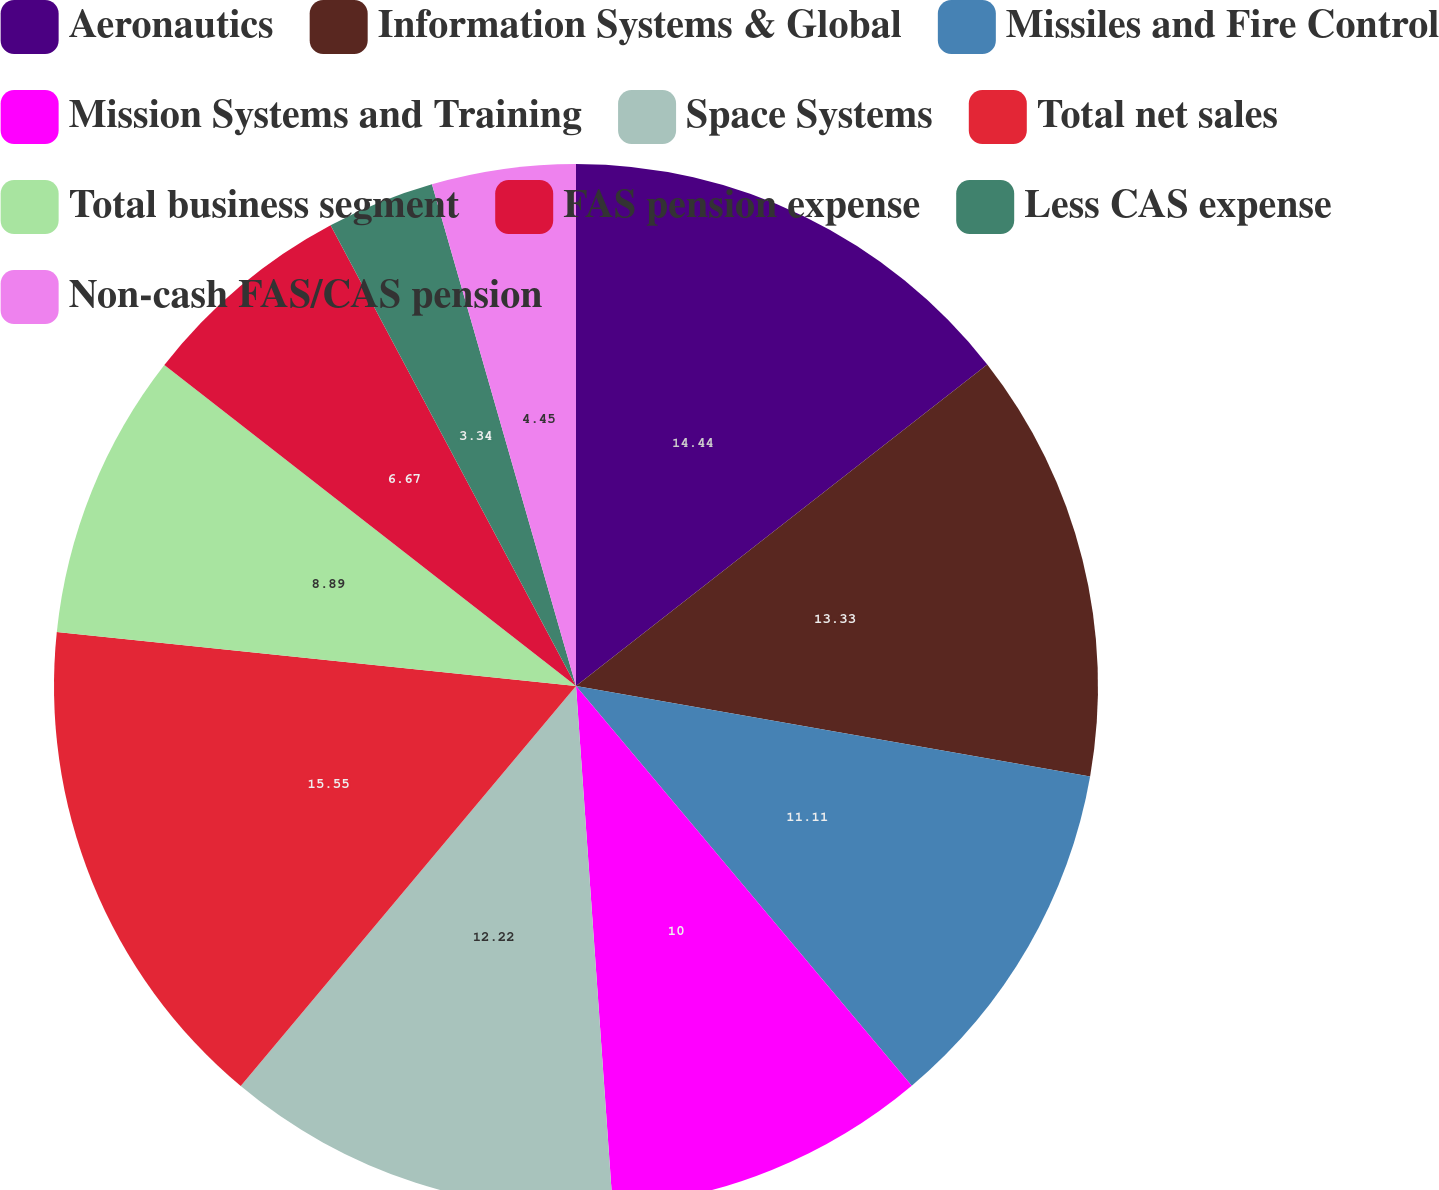<chart> <loc_0><loc_0><loc_500><loc_500><pie_chart><fcel>Aeronautics<fcel>Information Systems & Global<fcel>Missiles and Fire Control<fcel>Mission Systems and Training<fcel>Space Systems<fcel>Total net sales<fcel>Total business segment<fcel>FAS pension expense<fcel>Less CAS expense<fcel>Non-cash FAS/CAS pension<nl><fcel>14.44%<fcel>13.33%<fcel>11.11%<fcel>10.0%<fcel>12.22%<fcel>15.55%<fcel>8.89%<fcel>6.67%<fcel>3.34%<fcel>4.45%<nl></chart> 